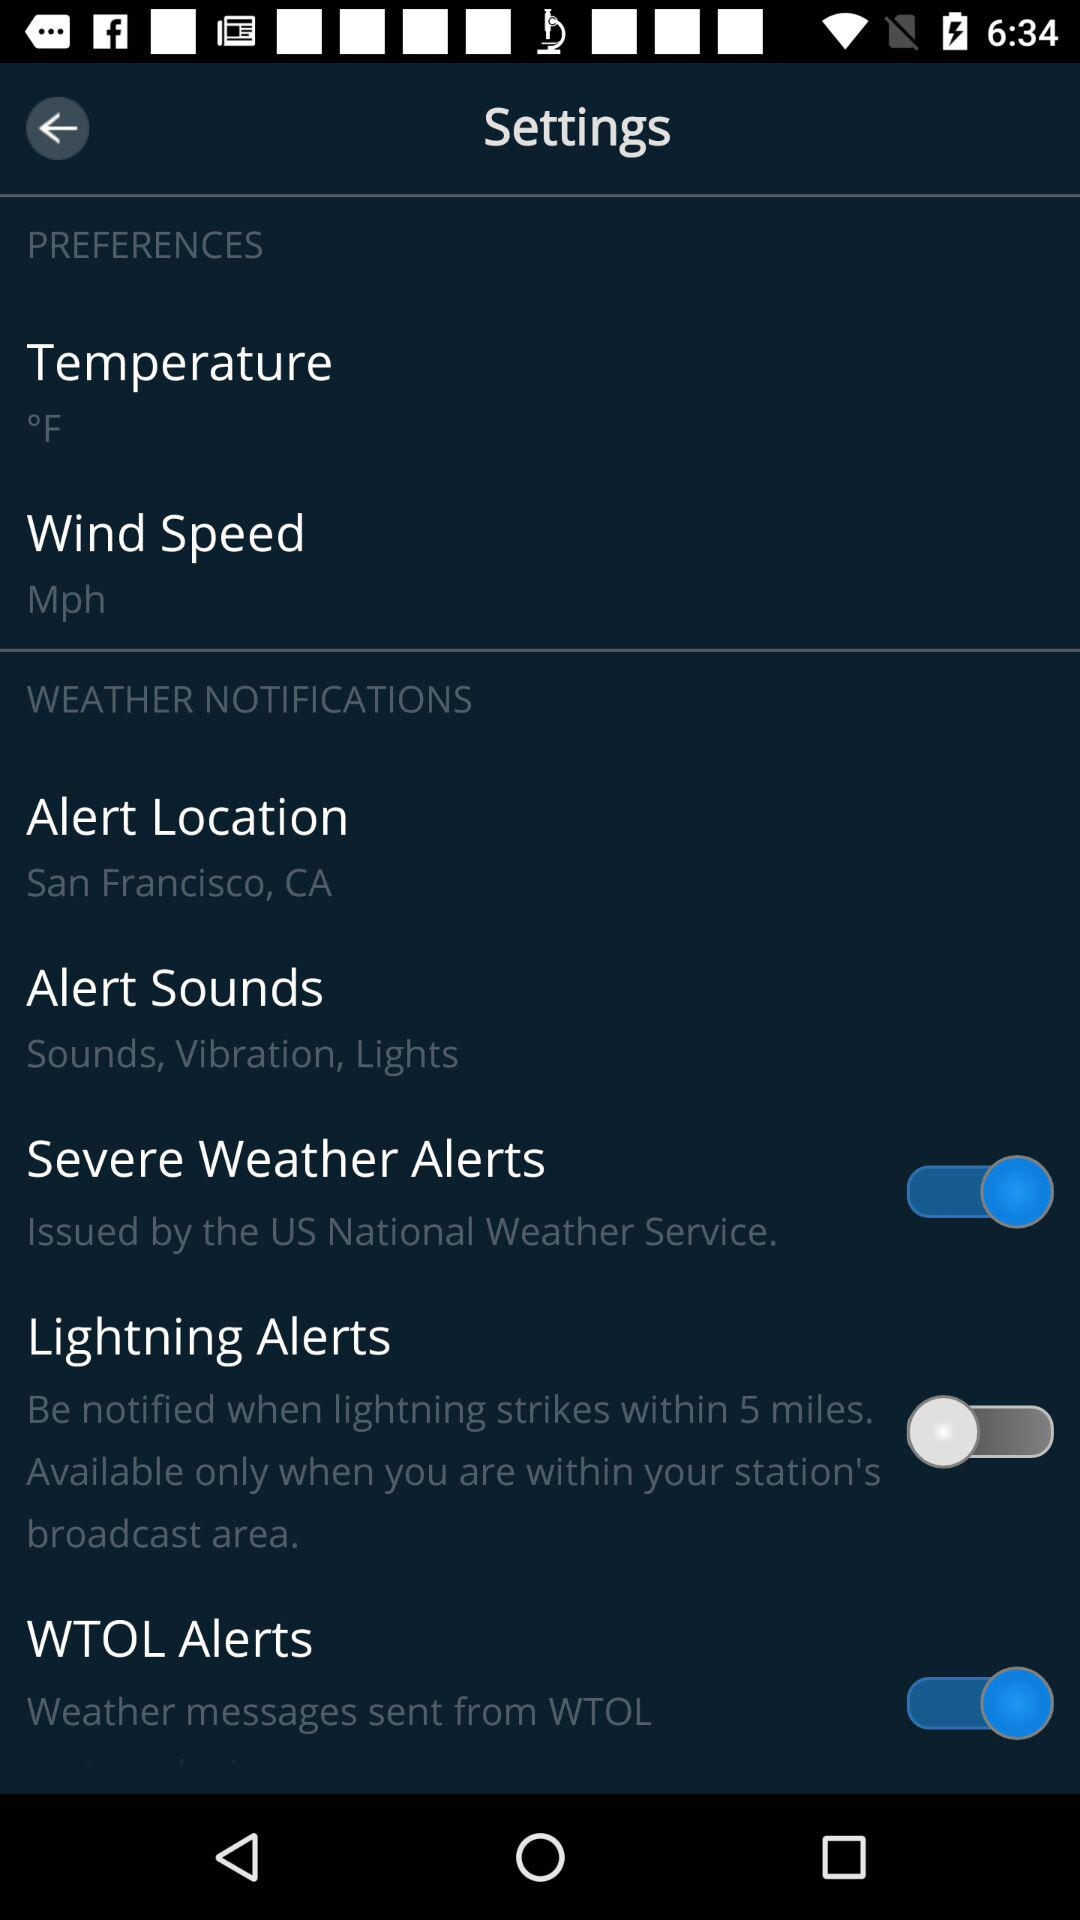Which alert option has been disabled? The alert option that has been disabled is "Lightning Alerts". 